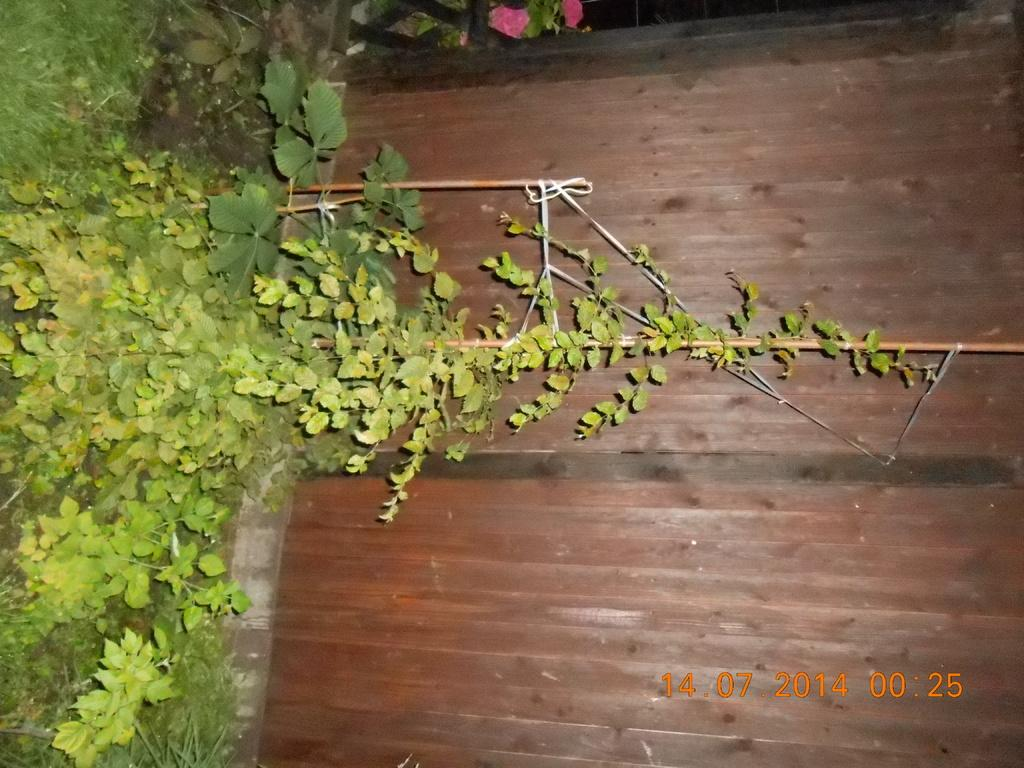What type of living organisms can be seen in the image? Plants and flowers are visible in the image. What color are the plants in the image? The plants are green. What color are the flowers in the image? The flowers are pink. What color is the background of the image? The background of the image is brown. What type of argument is taking place between the plants in the image? There is no argument present in the image; it features plants and flowers. What kind of cap is worn by the apparatus in the image? There is no apparatus present in the image, only plants and flowers. 